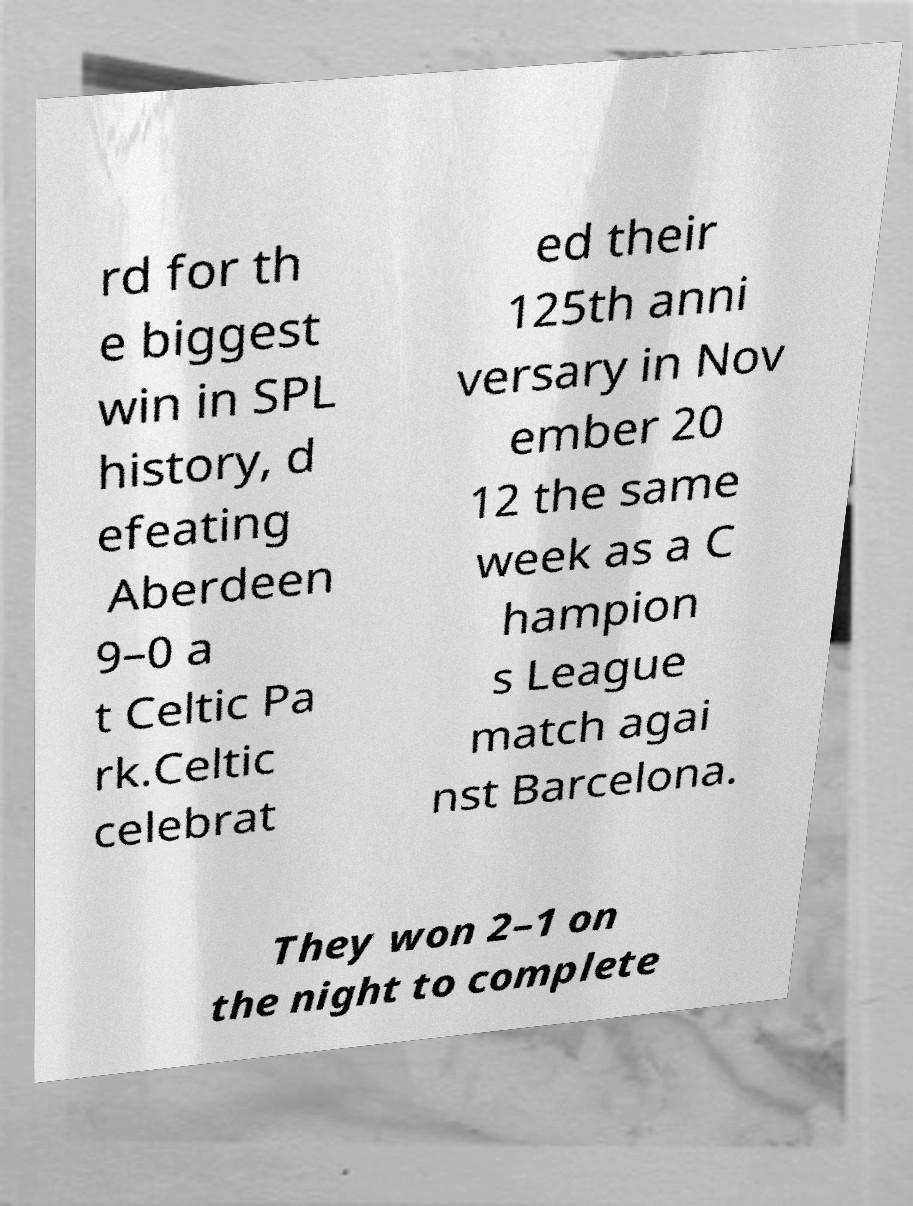What messages or text are displayed in this image? I need them in a readable, typed format. rd for th e biggest win in SPL history, d efeating Aberdeen 9–0 a t Celtic Pa rk.Celtic celebrat ed their 125th anni versary in Nov ember 20 12 the same week as a C hampion s League match agai nst Barcelona. They won 2–1 on the night to complete 